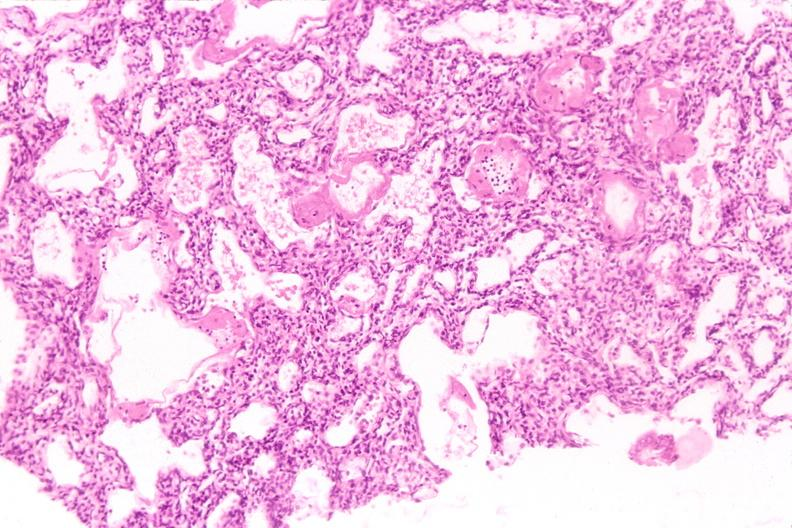does anaplastic astrocytoma show lungs, hyaline membrane disease?
Answer the question using a single word or phrase. No 